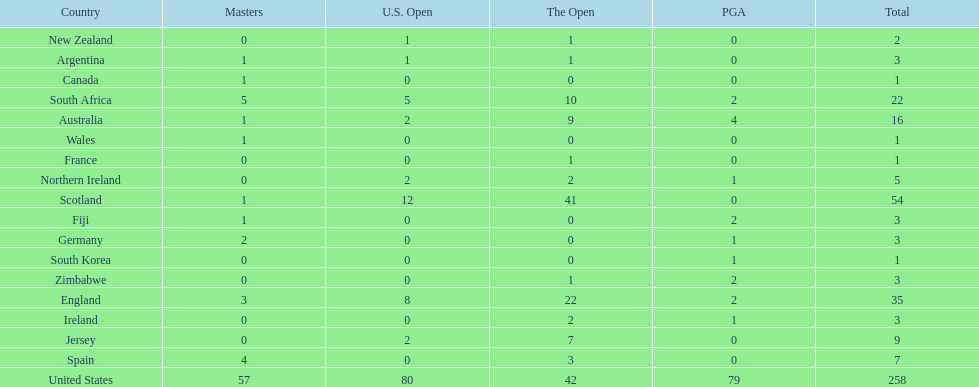What are all the countries? United States, Scotland, England, South Africa, Australia, Jersey, Spain, Northern Ireland, Argentina, Fiji, Germany, Ireland, Zimbabwe, New Zealand, Canada, France, South Korea, Wales. Which ones are located in africa? South Africa, Zimbabwe. Of those, which has the least champion golfers? Zimbabwe. 